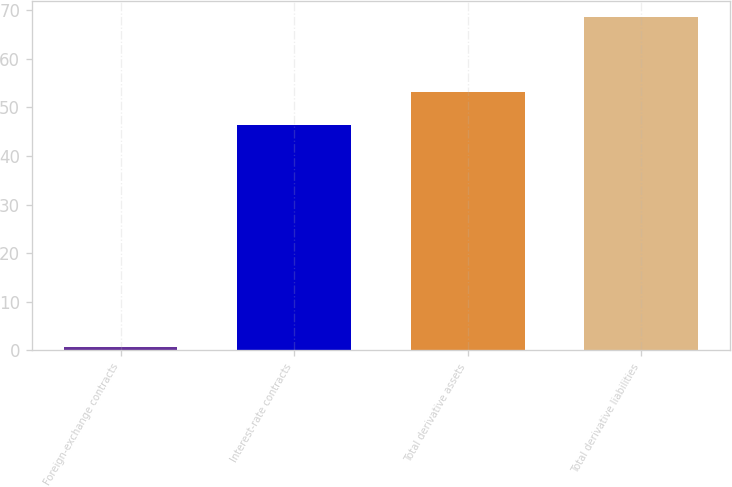<chart> <loc_0><loc_0><loc_500><loc_500><bar_chart><fcel>Foreign-exchange contracts<fcel>Interest-rate contracts<fcel>Total derivative assets<fcel>Total derivative liabilities<nl><fcel>0.6<fcel>46.3<fcel>53.1<fcel>68.6<nl></chart> 